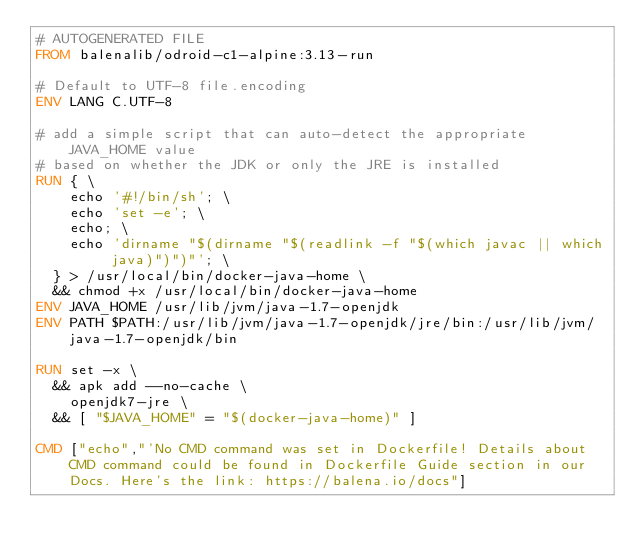<code> <loc_0><loc_0><loc_500><loc_500><_Dockerfile_># AUTOGENERATED FILE
FROM balenalib/odroid-c1-alpine:3.13-run

# Default to UTF-8 file.encoding
ENV LANG C.UTF-8

# add a simple script that can auto-detect the appropriate JAVA_HOME value
# based on whether the JDK or only the JRE is installed
RUN { \
		echo '#!/bin/sh'; \
		echo 'set -e'; \
		echo; \
		echo 'dirname "$(dirname "$(readlink -f "$(which javac || which java)")")"'; \
	} > /usr/local/bin/docker-java-home \
	&& chmod +x /usr/local/bin/docker-java-home
ENV JAVA_HOME /usr/lib/jvm/java-1.7-openjdk
ENV PATH $PATH:/usr/lib/jvm/java-1.7-openjdk/jre/bin:/usr/lib/jvm/java-1.7-openjdk/bin

RUN set -x \
	&& apk add --no-cache \
		openjdk7-jre \
	&& [ "$JAVA_HOME" = "$(docker-java-home)" ]

CMD ["echo","'No CMD command was set in Dockerfile! Details about CMD command could be found in Dockerfile Guide section in our Docs. Here's the link: https://balena.io/docs"]
</code> 